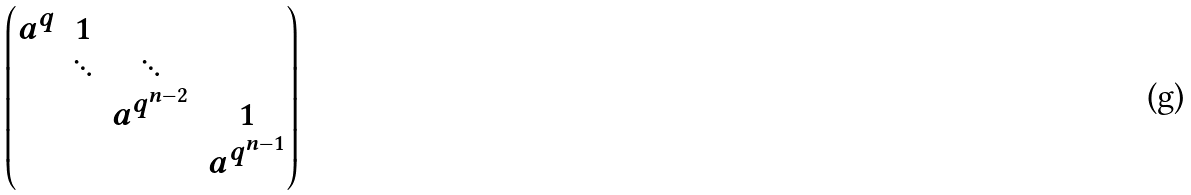<formula> <loc_0><loc_0><loc_500><loc_500>\begin{pmatrix} a ^ { q } & 1 \\ & \ddots & \ddots \\ & & a ^ { q ^ { n - 2 } } & 1 \\ & & & a ^ { q ^ { n - 1 } } \end{pmatrix}</formula> 